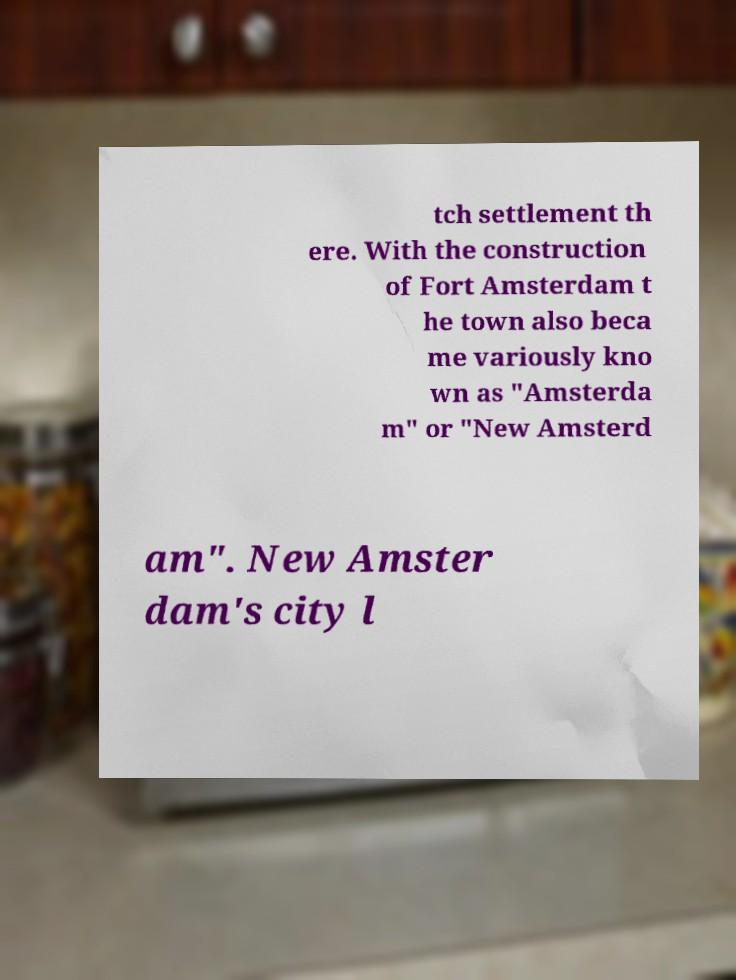Please identify and transcribe the text found in this image. tch settlement th ere. With the construction of Fort Amsterdam t he town also beca me variously kno wn as "Amsterda m" or "New Amsterd am". New Amster dam's city l 